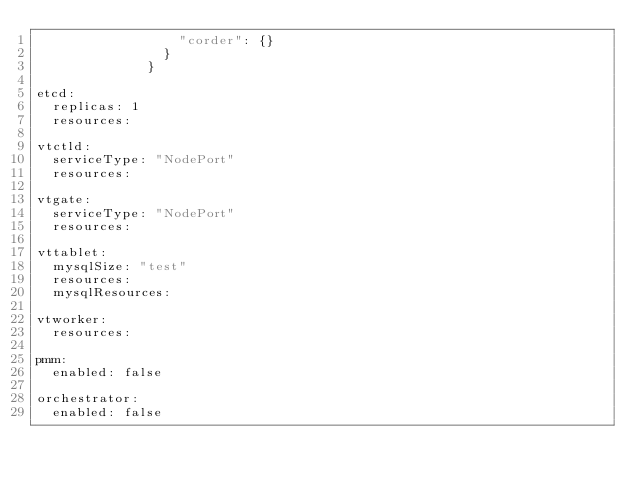<code> <loc_0><loc_0><loc_500><loc_500><_YAML_>                  "corder": {}
                }
              }

etcd:
  replicas: 1
  resources:

vtctld:
  serviceType: "NodePort"
  resources:

vtgate:
  serviceType: "NodePort"
  resources:

vttablet:
  mysqlSize: "test"
  resources:
  mysqlResources:

vtworker:
  resources:

pmm:
  enabled: false

orchestrator:
  enabled: false
</code> 